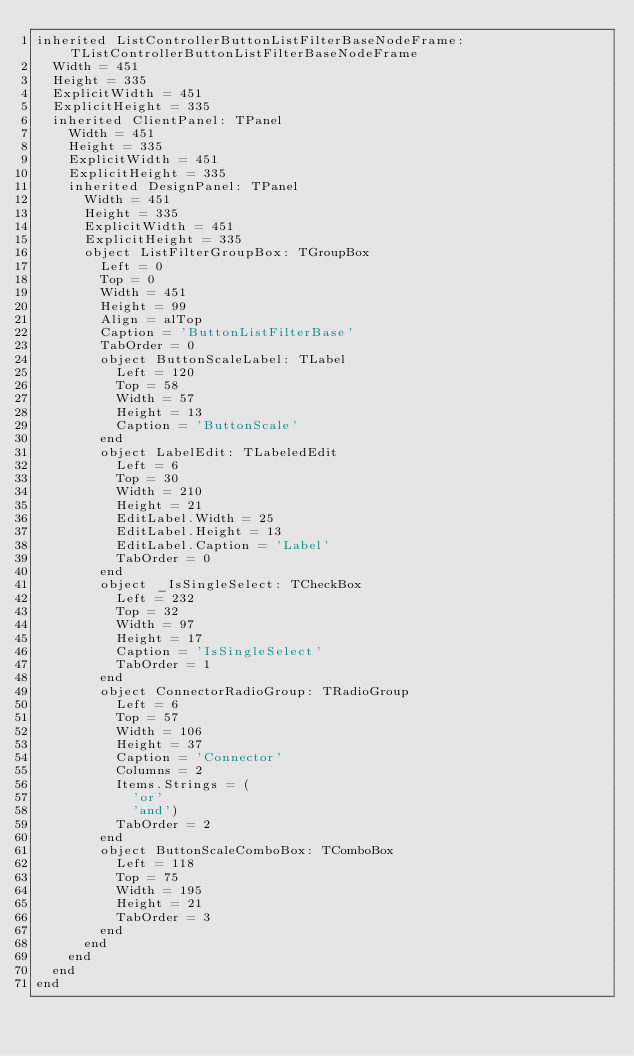Convert code to text. <code><loc_0><loc_0><loc_500><loc_500><_Pascal_>inherited ListControllerButtonListFilterBaseNodeFrame: TListControllerButtonListFilterBaseNodeFrame
  Width = 451
  Height = 335
  ExplicitWidth = 451
  ExplicitHeight = 335
  inherited ClientPanel: TPanel
    Width = 451
    Height = 335
    ExplicitWidth = 451
    ExplicitHeight = 335
    inherited DesignPanel: TPanel
      Width = 451
      Height = 335
      ExplicitWidth = 451
      ExplicitHeight = 335
      object ListFilterGroupBox: TGroupBox
        Left = 0
        Top = 0
        Width = 451
        Height = 99
        Align = alTop
        Caption = 'ButtonListFilterBase'
        TabOrder = 0
        object ButtonScaleLabel: TLabel
          Left = 120
          Top = 58
          Width = 57
          Height = 13
          Caption = 'ButtonScale'
        end
        object LabelEdit: TLabeledEdit
          Left = 6
          Top = 30
          Width = 210
          Height = 21
          EditLabel.Width = 25
          EditLabel.Height = 13
          EditLabel.Caption = 'Label'
          TabOrder = 0
        end
        object _IsSingleSelect: TCheckBox
          Left = 232
          Top = 32
          Width = 97
          Height = 17
          Caption = 'IsSingleSelect'
          TabOrder = 1
        end
        object ConnectorRadioGroup: TRadioGroup
          Left = 6
          Top = 57
          Width = 106
          Height = 37
          Caption = 'Connector'
          Columns = 2
          Items.Strings = (
            'or'
            'and')
          TabOrder = 2
        end
        object ButtonScaleComboBox: TComboBox
          Left = 118
          Top = 75
          Width = 195
          Height = 21
          TabOrder = 3
        end
      end
    end
  end
end
</code> 